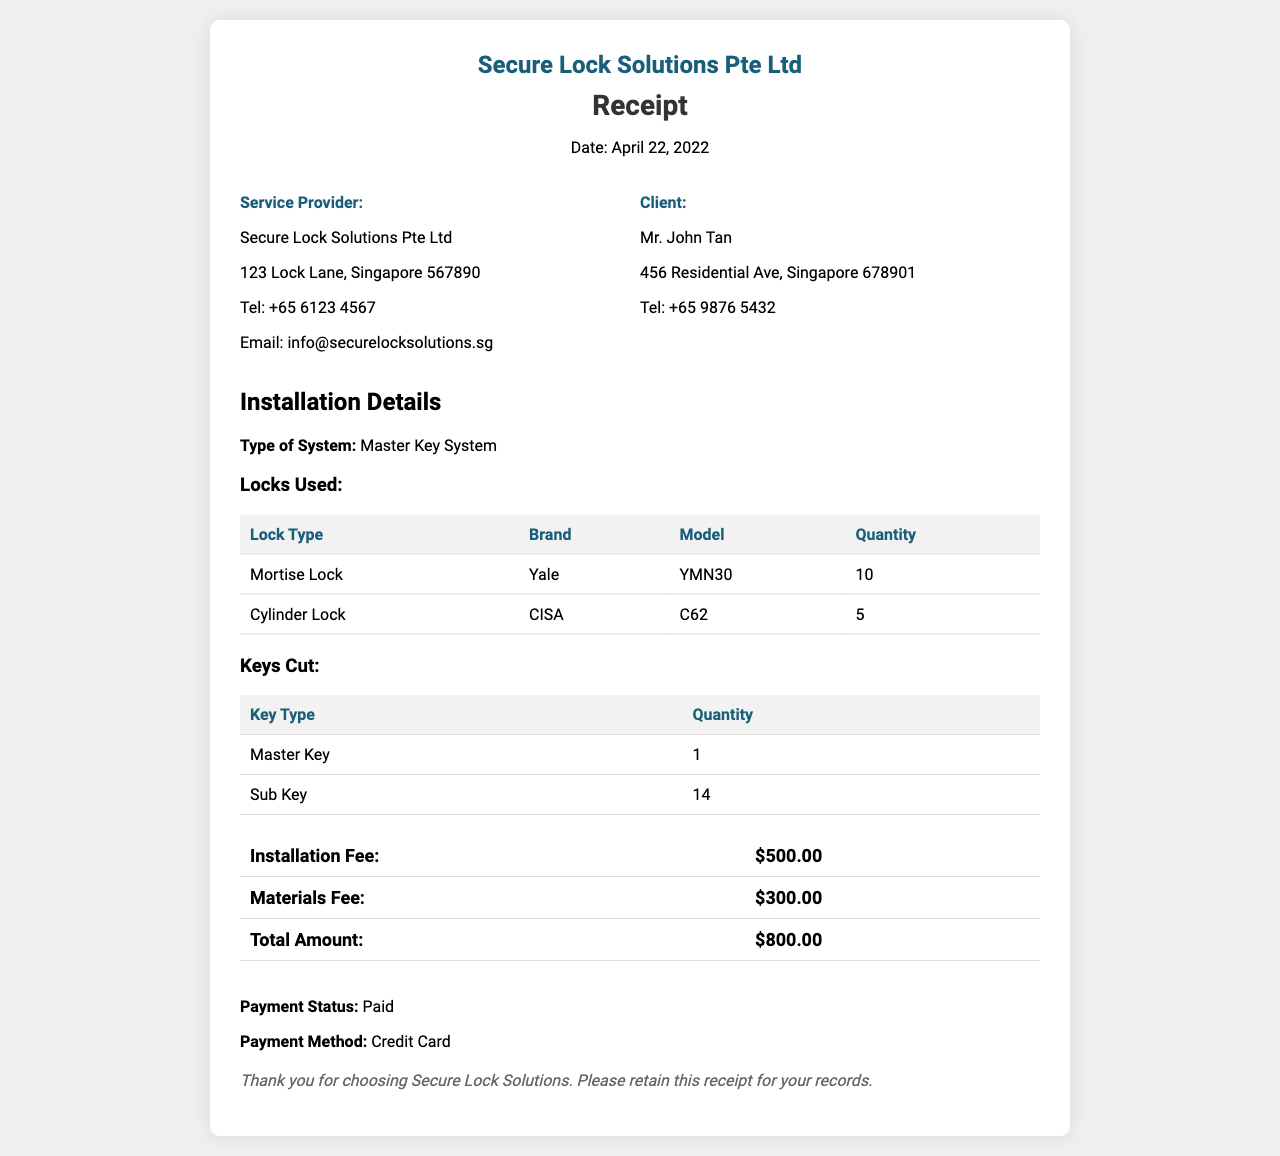What is the date of the installation? The installation date is explicitly mentioned in the receipt header as April 22, 2022.
Answer: April 22, 2022 What is the total amount charged? The total amount charged is summarized at the end of the receipt, amounting to $800.00.
Answer: $800.00 How many Mortise Locks were used? The details table shows that 10 Mortise Locks were listed under the locks used section.
Answer: 10 What type of key was cut in the least quantity? The keys cut section reveals that the Master Key was cut in the least quantity, which is 1.
Answer: Master Key What is the brand of the Cylinder Lock? The receipt specifically lists CISA as the brand for the Cylinder Lock in the locks used section.
Answer: CISA How many sub keys were cut? The keys cut section indicates that 14 Sub Keys were cut for the master key system.
Answer: 14 What was the installation fee? The total cost for installation is provided separately, listed as $500.00 in the fee summary.
Answer: $500.00 What was the payment method? The payment method is mentioned in the payment status section, which states it was done via Credit Card.
Answer: Credit Card What type of system was installed? The installation details section indicates that a Master Key System was installed.
Answer: Master Key System 